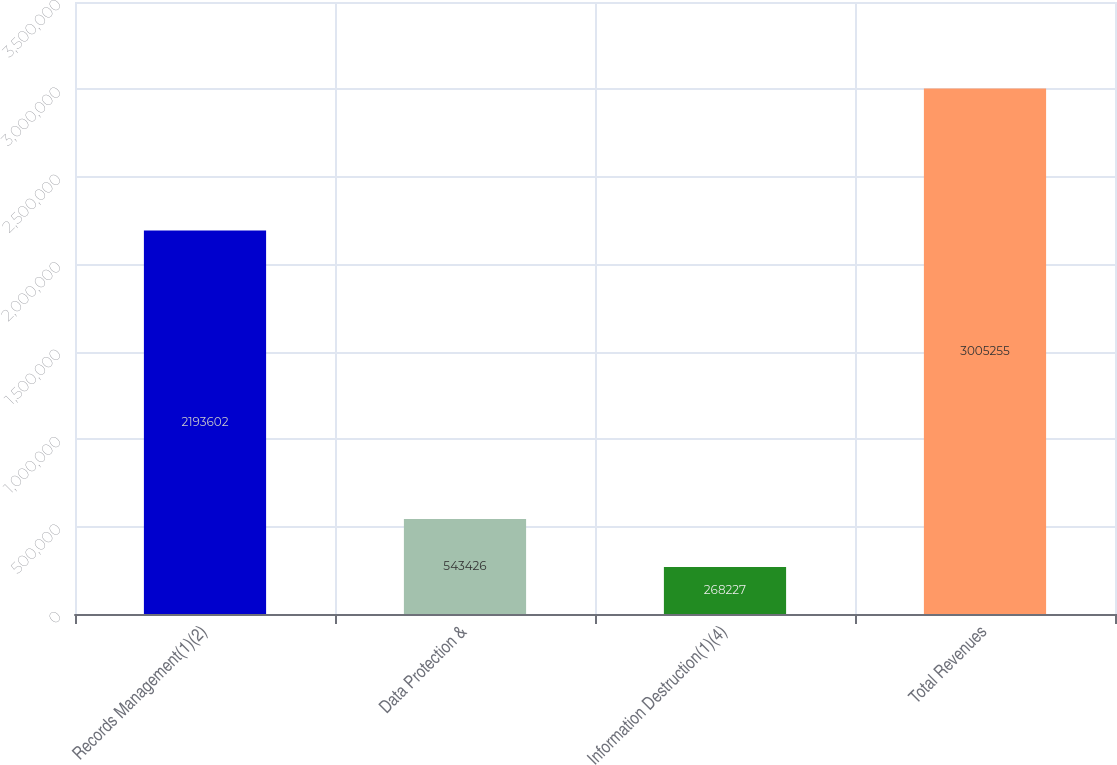Convert chart to OTSL. <chart><loc_0><loc_0><loc_500><loc_500><bar_chart><fcel>Records Management(1)(2)<fcel>Data Protection &<fcel>Information Destruction(1)(4)<fcel>Total Revenues<nl><fcel>2.1936e+06<fcel>543426<fcel>268227<fcel>3.00526e+06<nl></chart> 